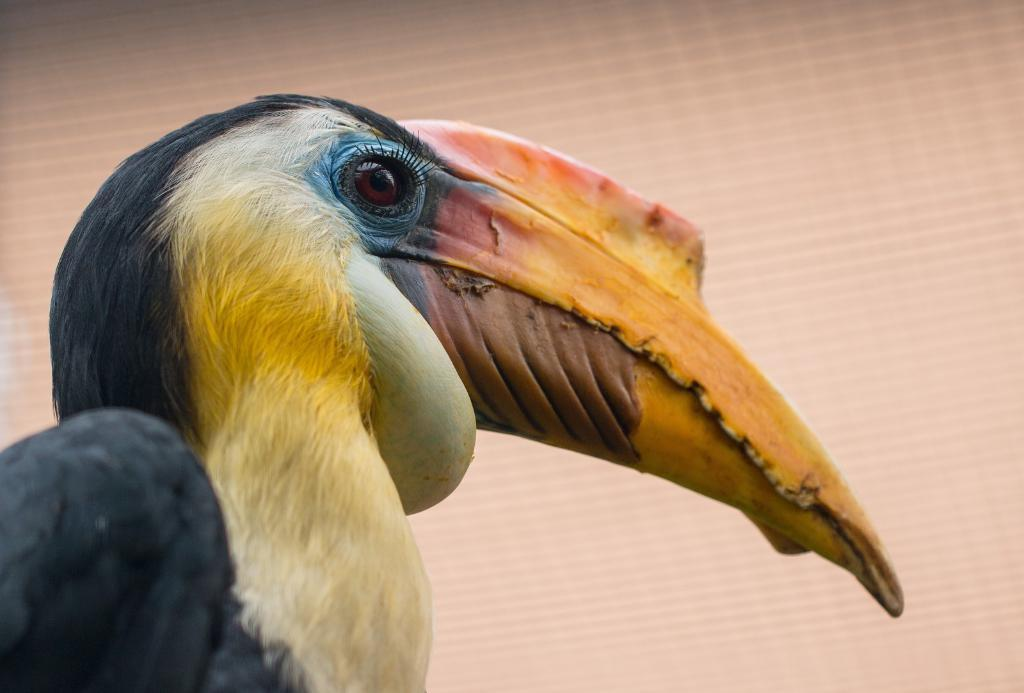What type of animal is in the image? There is a bird in the image. What colors can be seen on the bird? The bird has black, yellow, brown, blue, and cream colors. What is the color of the background in the image? The background of the image is brown. What level of the building does the person in the image live on? There is no person present in the image, only a bird. How does the bird move around in the image? The bird's movement cannot be determined from the image, as it is a still photograph. 